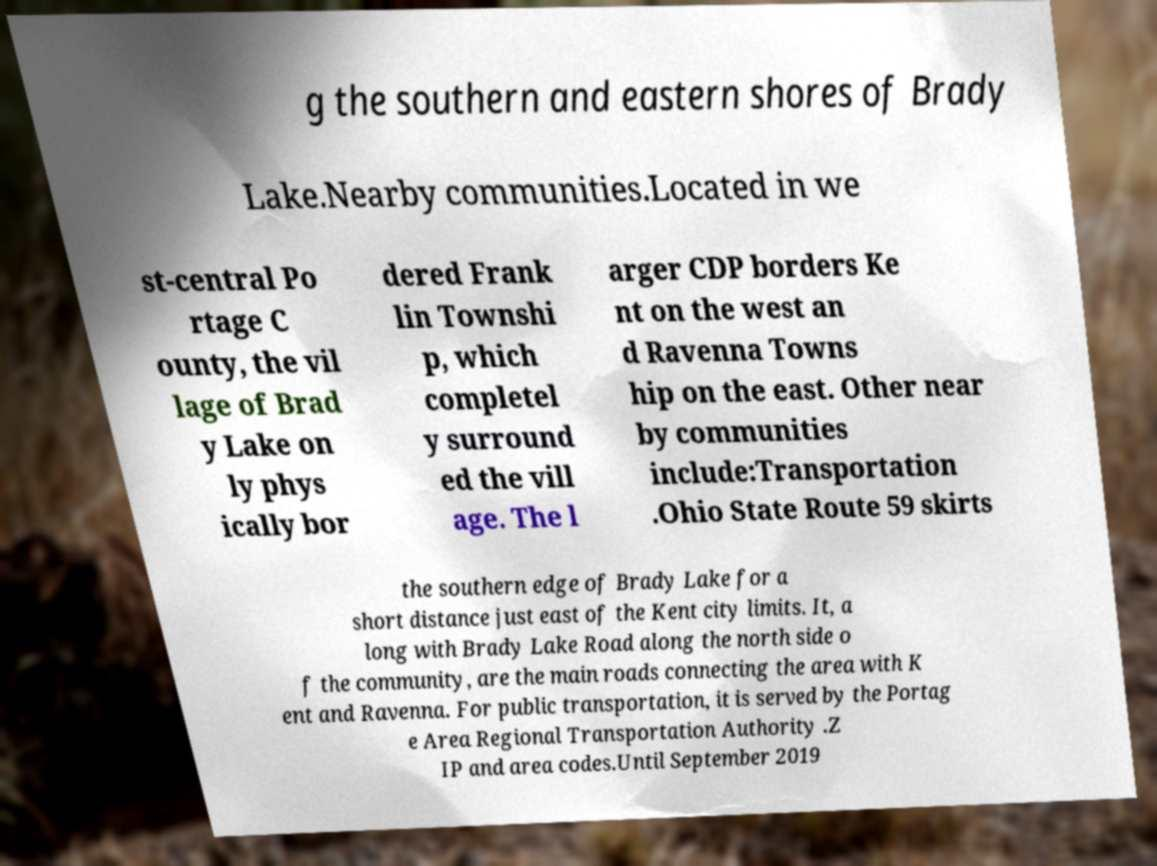Could you extract and type out the text from this image? g the southern and eastern shores of Brady Lake.Nearby communities.Located in we st-central Po rtage C ounty, the vil lage of Brad y Lake on ly phys ically bor dered Frank lin Townshi p, which completel y surround ed the vill age. The l arger CDP borders Ke nt on the west an d Ravenna Towns hip on the east. Other near by communities include:Transportation .Ohio State Route 59 skirts the southern edge of Brady Lake for a short distance just east of the Kent city limits. It, a long with Brady Lake Road along the north side o f the community, are the main roads connecting the area with K ent and Ravenna. For public transportation, it is served by the Portag e Area Regional Transportation Authority .Z IP and area codes.Until September 2019 